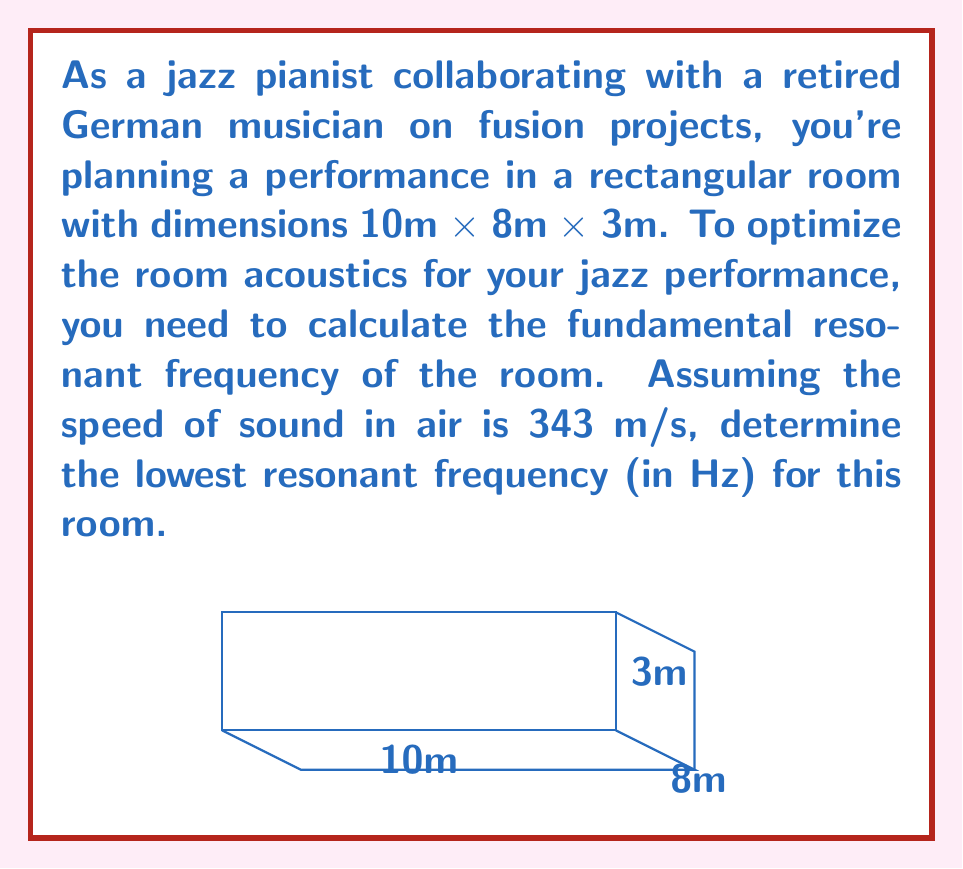Can you solve this math problem? To calculate the fundamental resonant frequency of a rectangular room, we use the following wave equation:

$$f = \frac{c}{2} \sqrt{\left(\frac{n_x}{L_x}\right)^2 + \left(\frac{n_y}{L_y}\right)^2 + \left(\frac{n_z}{L_z}\right)^2}$$

Where:
- $f$ is the resonant frequency
- $c$ is the speed of sound in air (343 m/s)
- $L_x$, $L_y$, and $L_z$ are the room dimensions
- $n_x$, $n_y$, and $n_z$ are integers representing the mode numbers

For the fundamental (lowest) resonant frequency, we use $n_x = n_y = n_z = 1$.

Step 1: Substitute the given values into the equation:
$$f = \frac{343}{2} \sqrt{\left(\frac{1}{10}\right)^2 + \left(\frac{1}{8}\right)^2 + \left(\frac{1}{3}\right)^2}$$

Step 2: Simplify the expression under the square root:
$$f = \frac{343}{2} \sqrt{0.01 + 0.015625 + 0.111111}$$
$$f = \frac{343}{2} \sqrt{0.136736}$$

Step 3: Calculate the final result:
$$f = 171.5 \times 0.369779 = 63.4178 \text{ Hz}$$

Step 4: Round to the nearest whole number:
$$f \approx 63 \text{ Hz}$$
Answer: 63 Hz 